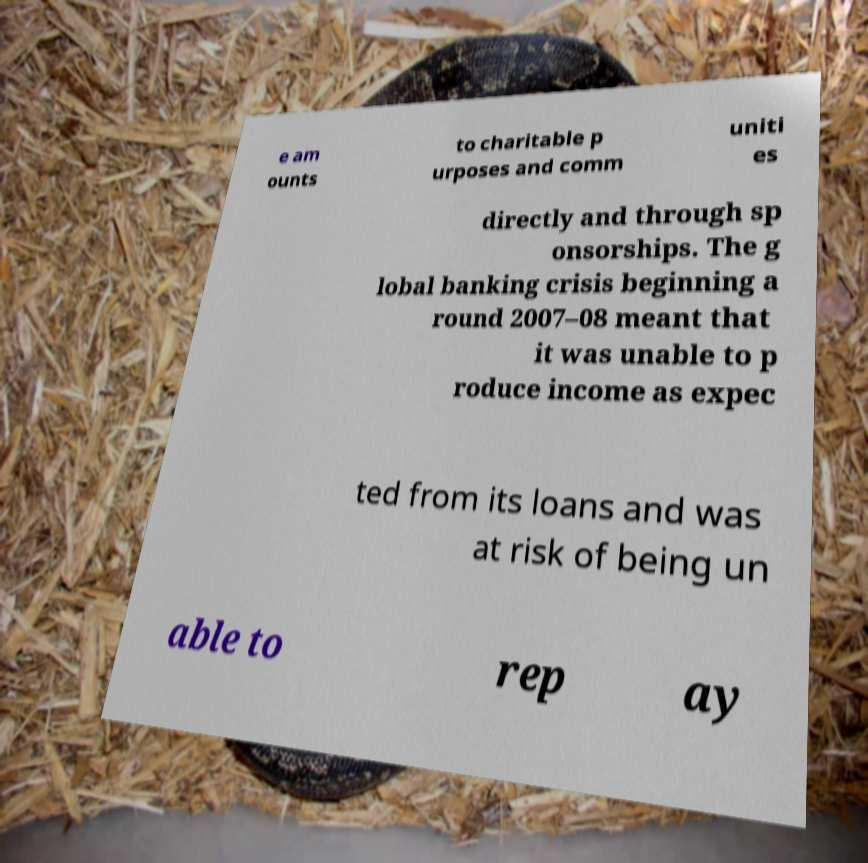There's text embedded in this image that I need extracted. Can you transcribe it verbatim? e am ounts to charitable p urposes and comm uniti es directly and through sp onsorships. The g lobal banking crisis beginning a round 2007–08 meant that it was unable to p roduce income as expec ted from its loans and was at risk of being un able to rep ay 